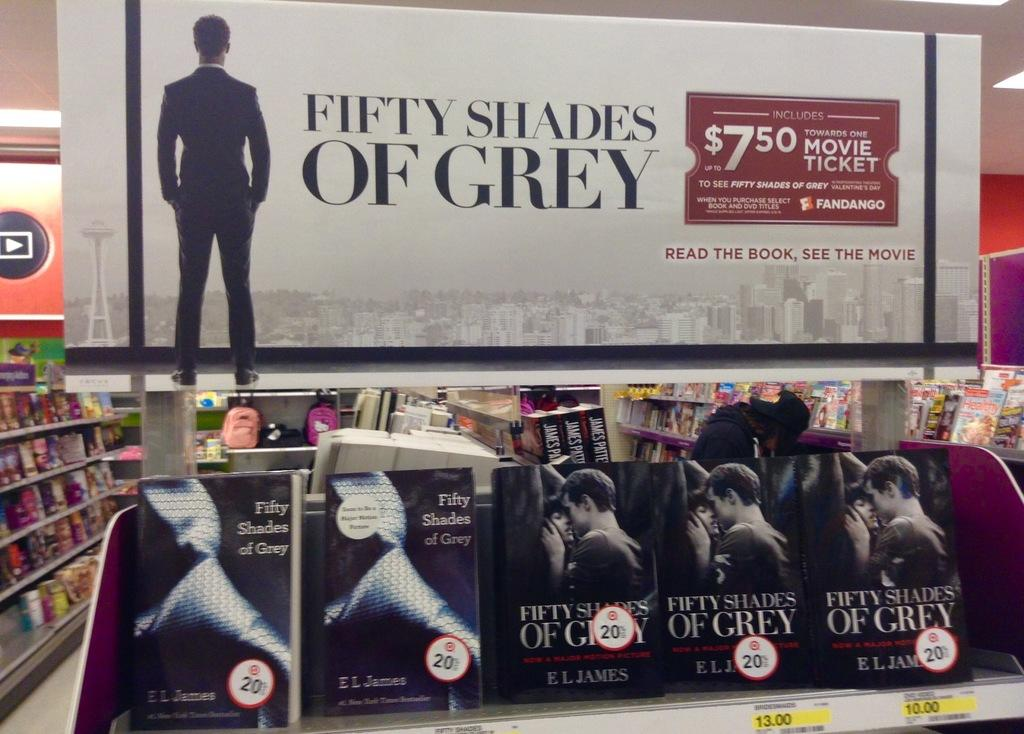<image>
Share a concise interpretation of the image provided. A poster for Fifty Shades of Grey is above a row of book shelves. 